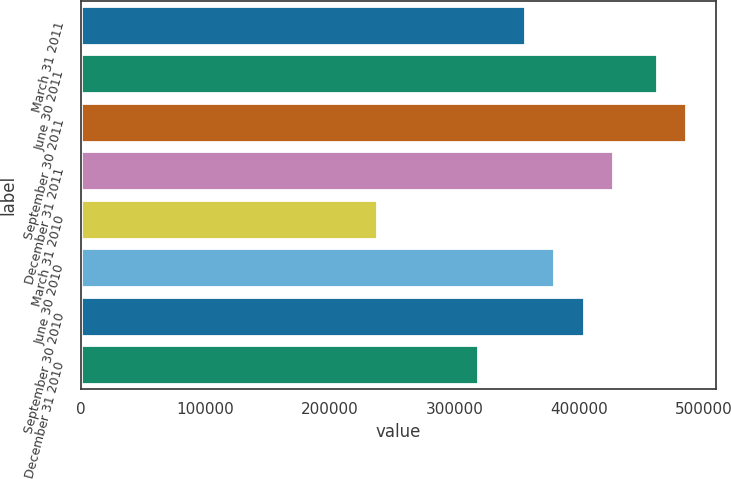<chart> <loc_0><loc_0><loc_500><loc_500><bar_chart><fcel>March 31 2011<fcel>June 30 2011<fcel>September 30 2011<fcel>December 31 2011<fcel>March 31 2010<fcel>June 30 2010<fcel>September 30 2010<fcel>December 31 2010<nl><fcel>356419<fcel>462145<fcel>485805<fcel>427399<fcel>238110<fcel>380079<fcel>403739<fcel>318665<nl></chart> 